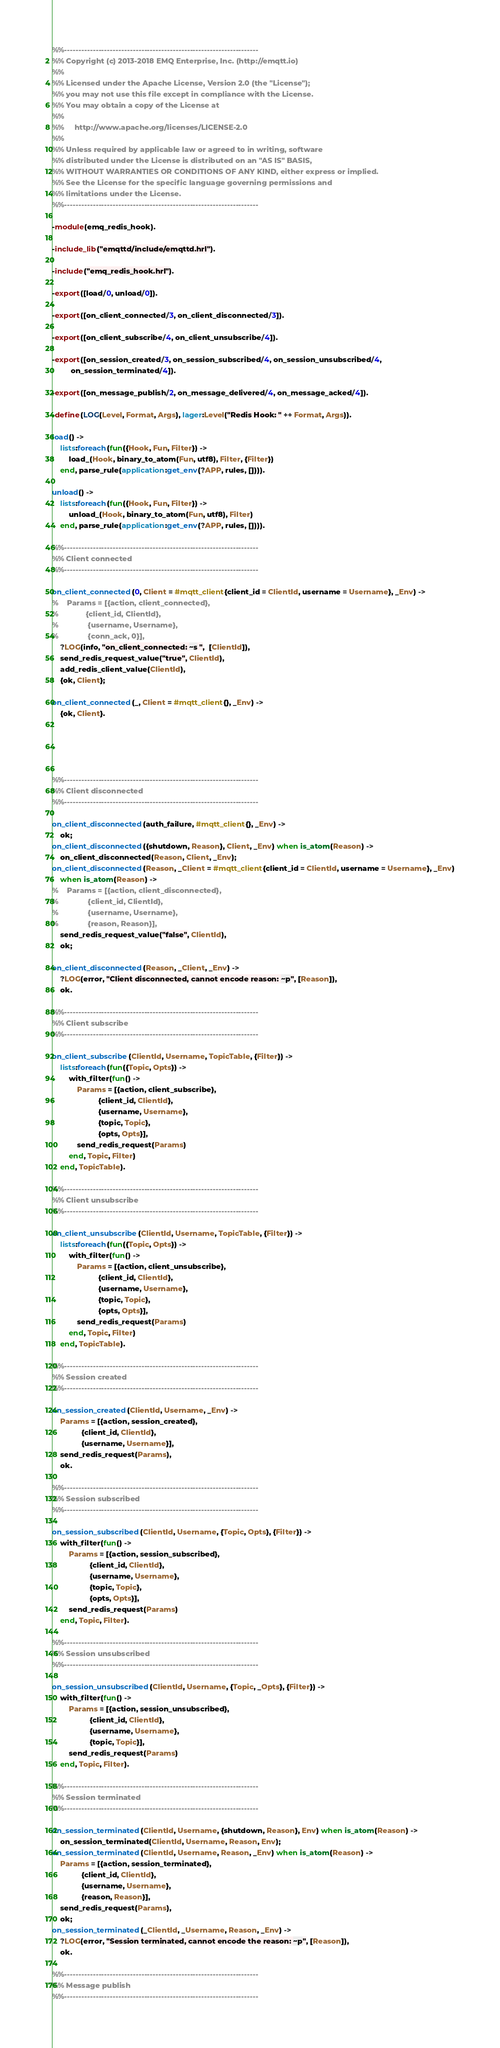Convert code to text. <code><loc_0><loc_0><loc_500><loc_500><_Erlang_>%%--------------------------------------------------------------------
%% Copyright (c) 2013-2018 EMQ Enterprise, Inc. (http://emqtt.io)
%%
%% Licensed under the Apache License, Version 2.0 (the "License");
%% you may not use this file except in compliance with the License.
%% You may obtain a copy of the License at
%%
%%     http://www.apache.org/licenses/LICENSE-2.0
%%
%% Unless required by applicable law or agreed to in writing, software
%% distributed under the License is distributed on an "AS IS" BASIS,
%% WITHOUT WARRANTIES OR CONDITIONS OF ANY KIND, either express or implied.
%% See the License for the specific language governing permissions and
%% limitations under the License.
%%--------------------------------------------------------------------

-module(emq_redis_hook).

-include_lib("emqttd/include/emqttd.hrl").

-include("emq_redis_hook.hrl").

-export([load/0, unload/0]).

-export([on_client_connected/3, on_client_disconnected/3]).

-export([on_client_subscribe/4, on_client_unsubscribe/4]).

-export([on_session_created/3, on_session_subscribed/4, on_session_unsubscribed/4,
         on_session_terminated/4]).

-export([on_message_publish/2, on_message_delivered/4, on_message_acked/4]).

-define(LOG(Level, Format, Args), lager:Level("Redis Hook: " ++ Format, Args)).

load() ->
    lists:foreach(fun({Hook, Fun, Filter}) ->
        load_(Hook, binary_to_atom(Fun, utf8), Filter, {Filter})
    end, parse_rule(application:get_env(?APP, rules, []))).

unload() ->
    lists:foreach(fun({Hook, Fun, Filter}) ->
        unload_(Hook, binary_to_atom(Fun, utf8), Filter)
    end, parse_rule(application:get_env(?APP, rules, []))).

%%--------------------------------------------------------------------
%% Client connected
%%--------------------------------------------------------------------

on_client_connected(0, Client = #mqtt_client{client_id = ClientId, username = Username}, _Env) ->
%    Params = [{action, client_connected},
%             {client_id, ClientId},
%              {username, Username},
%              {conn_ack, 0}],
    ?LOG(info, "on_client_connected: ~s ",  [ClientId]),
    send_redis_request_value("true", ClientId),
    add_redis_client_value(ClientId),
    {ok, Client};

on_client_connected(_, Client = #mqtt_client{}, _Env) ->
    {ok, Client}.





%%--------------------------------------------------------------------
%% Client disconnected
%%--------------------------------------------------------------------

on_client_disconnected(auth_failure, #mqtt_client{}, _Env) ->
    ok;
on_client_disconnected({shutdown, Reason}, Client, _Env) when is_atom(Reason) ->
    on_client_disconnected(Reason, Client, _Env);
on_client_disconnected(Reason, _Client = #mqtt_client{client_id = ClientId, username = Username}, _Env)
    when is_atom(Reason) ->
%    Params = [{action, client_disconnected},
%              {client_id, ClientId},
%              {username, Username},
%              {reason, Reason}],
    send_redis_request_value("false", ClientId),
    ok;

on_client_disconnected(Reason, _Client, _Env) ->
    ?LOG(error, "Client disconnected, cannot encode reason: ~p", [Reason]),
    ok.

%%--------------------------------------------------------------------
%% Client subscribe
%%--------------------------------------------------------------------

on_client_subscribe(ClientId, Username, TopicTable, {Filter}) ->
    lists:foreach(fun({Topic, Opts}) ->
        with_filter(fun() ->
            Params = [{action, client_subscribe},
                      {client_id, ClientId},
                      {username, Username},
                      {topic, Topic},
                      {opts, Opts}],
            send_redis_request(Params)
        end, Topic, Filter)
    end, TopicTable).

%%--------------------------------------------------------------------
%% Client unsubscribe
%%--------------------------------------------------------------------

on_client_unsubscribe(ClientId, Username, TopicTable, {Filter}) ->
    lists:foreach(fun({Topic, Opts}) ->
        with_filter(fun() ->
            Params = [{action, client_unsubscribe},
                      {client_id, ClientId},
                      {username, Username},
                      {topic, Topic},
                      {opts, Opts}],
            send_redis_request(Params)
        end, Topic, Filter)
    end, TopicTable).

%%--------------------------------------------------------------------
%% Session created
%%--------------------------------------------------------------------

on_session_created(ClientId, Username, _Env) ->
    Params = [{action, session_created},
              {client_id, ClientId},
              {username, Username}],
    send_redis_request(Params),
    ok.

%%--------------------------------------------------------------------
%% Session subscribed
%%--------------------------------------------------------------------

on_session_subscribed(ClientId, Username, {Topic, Opts}, {Filter}) ->
    with_filter(fun() ->
        Params = [{action, session_subscribed},
                  {client_id, ClientId},
                  {username, Username},
                  {topic, Topic},
                  {opts, Opts}],
        send_redis_request(Params)
    end, Topic, Filter).

%%--------------------------------------------------------------------
%% Session unsubscribed
%%--------------------------------------------------------------------

on_session_unsubscribed(ClientId, Username, {Topic, _Opts}, {Filter}) ->
    with_filter(fun() ->
        Params = [{action, session_unsubscribed},
                  {client_id, ClientId},
                  {username, Username},
                  {topic, Topic}],
        send_redis_request(Params)
    end, Topic, Filter).

%%--------------------------------------------------------------------
%% Session terminated
%%--------------------------------------------------------------------

on_session_terminated(ClientId, Username, {shutdown, Reason}, Env) when is_atom(Reason) ->
    on_session_terminated(ClientId, Username, Reason, Env);
on_session_terminated(ClientId, Username, Reason, _Env) when is_atom(Reason) ->
    Params = [{action, session_terminated},
              {client_id, ClientId},
              {username, Username},
              {reason, Reason}],
    send_redis_request(Params),
    ok;
on_session_terminated(_ClientId, _Username, Reason, _Env) ->
    ?LOG(error, "Session terminated, cannot encode the reason: ~p", [Reason]),
    ok.

%%--------------------------------------------------------------------
%% Message publish
%%--------------------------------------------------------------------
</code> 